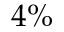<formula> <loc_0><loc_0><loc_500><loc_500>4 \%</formula> 